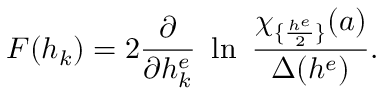Convert formula to latex. <formula><loc_0><loc_0><loc_500><loc_500>F ( h _ { k } ) = 2 { \frac { \partial } { \partial h _ { k } ^ { e } } } \ln \ { \frac { \chi _ { \{ { \frac { h ^ { e } } { 2 } } \} } ( a ) } { \Delta ( h ^ { e } ) } } .</formula> 